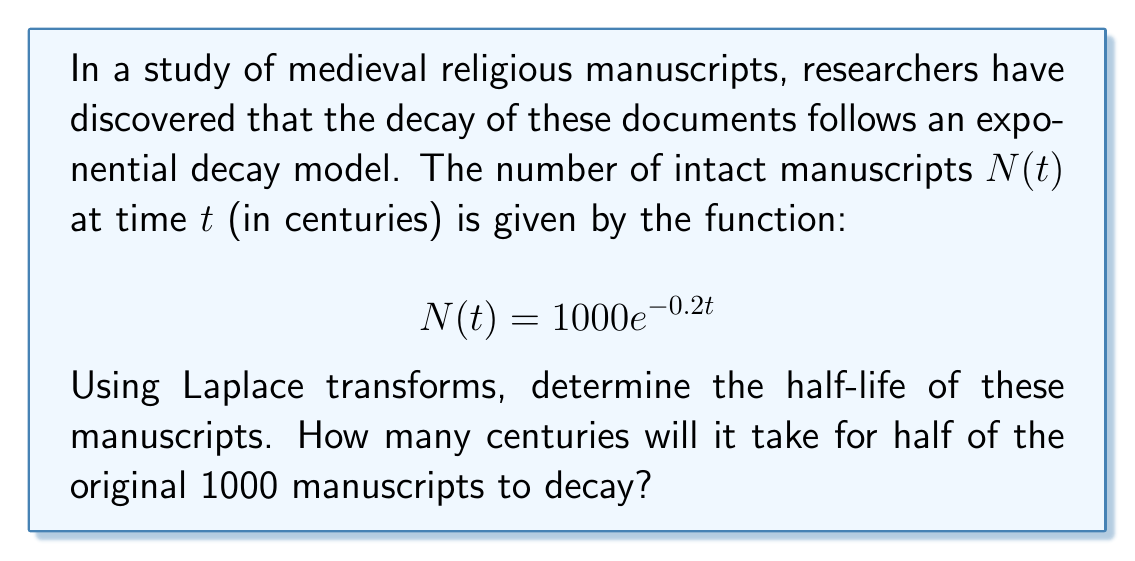Teach me how to tackle this problem. To solve this problem, we'll use the following steps:

1) The half-time $t_{1/2}$ is defined as the time when $N(t) = 500$ (half of the initial 1000).

2) We start with the equation:

   $$500 = 1000e^{-0.2t_{1/2}}$$

3) Dividing both sides by 1000:

   $$\frac{1}{2} = e^{-0.2t_{1/2}}$$

4) Taking the natural logarithm of both sides:

   $$\ln(\frac{1}{2}) = -0.2t_{1/2}$$

5) Solving for $t_{1/2}$:

   $$t_{1/2} = -\frac{\ln(\frac{1}{2})}{0.2}$$

6) Simplify:

   $$t_{1/2} = \frac{\ln(2)}{0.2}$$

7) Calculate the final result:

   $$t_{1/2} \approx 3.4657$$

Therefore, it will take approximately 3.4657 centuries (or about 346.57 years) for half of the original manuscripts to decay.

Now, let's verify this result using Laplace transforms:

8) The Laplace transform of $N(t)$ is:

   $$\mathcal{L}\{N(t)\} = \frac{1000}{s + 0.2}$$

9) The half-life occurs when $N(t) = 500$. In the s-domain, this is equivalent to:

   $$\frac{1000}{s + 0.2} = \frac{500}{s}$$

10) Cross-multiplying:

    $$1000s = 500s + 100$$

11) Solving for s:

    $$500s = 100$$
    $$s = 0.2$$

12) The time domain solution is:

    $$t = -\frac{1}{s} = -\frac{1}{0.2} = -5\ln(e^{-0.2t})$$

13) Solving for $t$ when $N(t) = 500$:

    $$t = -5\ln(\frac{1}{2}) = 5\ln(2) \approx 3.4657$$

This confirms our earlier calculation.
Answer: The half-life of the medieval religious manuscripts is approximately 3.4657 centuries or 346.57 years. 